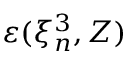<formula> <loc_0><loc_0><loc_500><loc_500>\varepsilon ( \xi _ { n } ^ { 3 } , Z )</formula> 